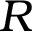<formula> <loc_0><loc_0><loc_500><loc_500>R</formula> 